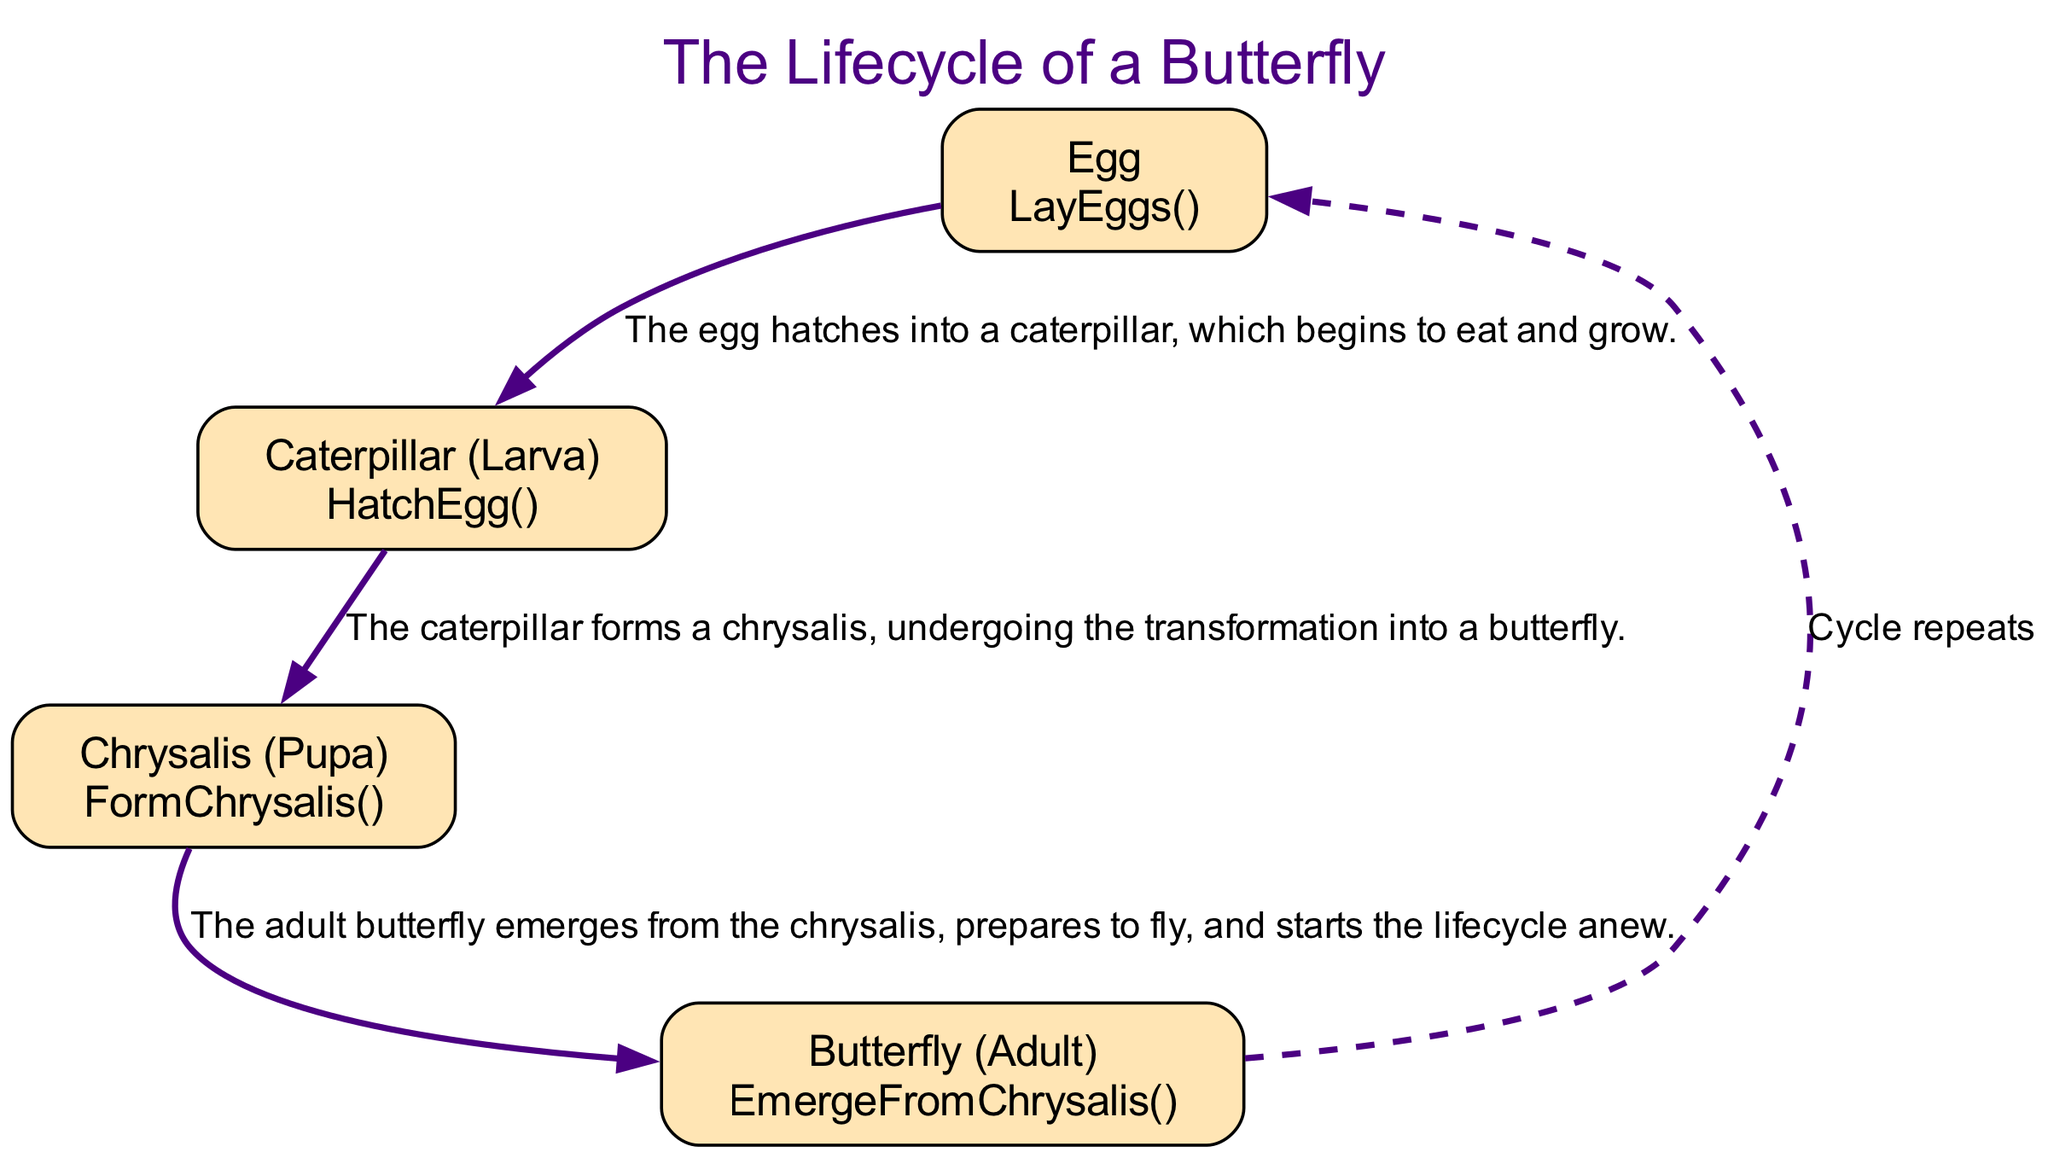What is the first stage in the lifecycle of a butterfly? The diagram starts with the "Egg" stage, which is the initial point in the lifecycle.
Answer: Egg How many stages are there in the lifecycle of a butterfly? The diagram shows four distinct stages: Egg, Caterpillar (Larva), Chrysalis (Pupa), and Butterfly (Adult), totaling four stages.
Answer: Four What does the "Caterpillar (Larva)" stage do? The description for the "Caterpillar (Larva)" node states that it hatches from the egg and begins to eat and grow, indicating its main activity in this stage.
Answer: Eats and grows Which function corresponds to the "Chrysalis (Pupa)"? In the diagram, the "Chrysalis (Pupa)" stage is associated with the function "FormChrysalis()" which signifies the act of forming a chrysalis.
Answer: FormChrysalis() What happens after the "Butterfly (Adult)" stage? The edge from the "Butterfly (Adult)" stage back to the "Egg" stage is labeled "Cycle repeats," indicating the lifecycle starts anew after the adult butterfly emerges.
Answer: Cycle repeats How does the transition from the "Caterpillar (Larva)" to "Chrysalis (Pupa)" occur? The diagram connects these stages with a directed edge that describes the process as "The caterpillar forms a chrysalis," signifying a transformation takes place.
Answer: The caterpillar forms a chrysalis What is the relationship between the "Egg" and "Caterpillar (Larva)" stages? The diagram has an edge connecting the "Egg" stage to the "Caterpillar (Larva)" stage, with a description indicating that "The egg hatches into a caterpillar."
Answer: Hatches into What does the dashed edge signify in the diagram? The dashed edge in the diagram indicates a cycle, specifically showing that the completion of the lifecycle returns to the start, which is the "Egg" stage.
Answer: Cycle completion What stage comes immediately after "Chrysalis (Pupa)"? In the order presented in the flowchart, the "Butterfly (Adult)" stage immediately follows the "Chrysalis (Pupa)" stage, representing the next phase in the lifecycle.
Answer: Butterfly (Adult) 